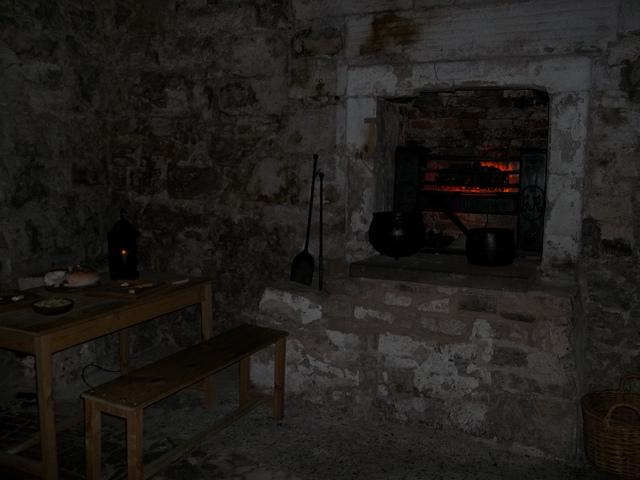What type of heat is shown? fire 